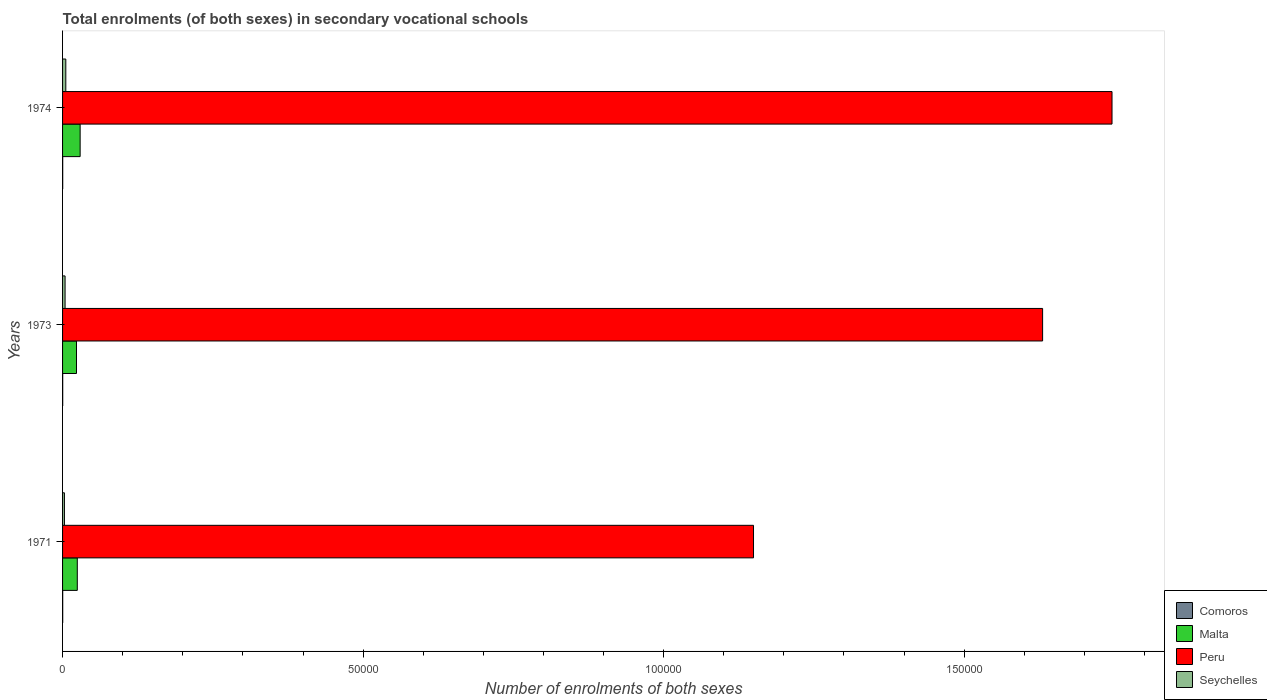How many bars are there on the 2nd tick from the top?
Provide a short and direct response. 4. What is the label of the 1st group of bars from the top?
Your answer should be very brief. 1974. What is the number of enrolments in secondary schools in Malta in 1973?
Make the answer very short. 2319. Across all years, what is the maximum number of enrolments in secondary schools in Peru?
Keep it short and to the point. 1.75e+05. Across all years, what is the minimum number of enrolments in secondary schools in Seychelles?
Provide a short and direct response. 312. In which year was the number of enrolments in secondary schools in Peru maximum?
Your answer should be compact. 1974. What is the total number of enrolments in secondary schools in Malta in the graph?
Keep it short and to the point. 7694. What is the difference between the number of enrolments in secondary schools in Peru in 1971 and that in 1973?
Offer a terse response. -4.81e+04. What is the difference between the number of enrolments in secondary schools in Comoros in 1971 and the number of enrolments in secondary schools in Seychelles in 1973?
Your answer should be compact. -394. What is the average number of enrolments in secondary schools in Peru per year?
Give a very brief answer. 1.51e+05. In the year 1971, what is the difference between the number of enrolments in secondary schools in Peru and number of enrolments in secondary schools in Seychelles?
Your answer should be compact. 1.15e+05. In how many years, is the number of enrolments in secondary schools in Comoros greater than 100000 ?
Offer a terse response. 0. What is the ratio of the number of enrolments in secondary schools in Seychelles in 1971 to that in 1974?
Your answer should be very brief. 0.58. Is the number of enrolments in secondary schools in Peru in 1971 less than that in 1973?
Give a very brief answer. Yes. What is the difference between the highest and the second highest number of enrolments in secondary schools in Peru?
Offer a very short reply. 1.15e+04. What is the difference between the highest and the lowest number of enrolments in secondary schools in Comoros?
Offer a very short reply. 2. In how many years, is the number of enrolments in secondary schools in Peru greater than the average number of enrolments in secondary schools in Peru taken over all years?
Your answer should be compact. 2. What does the 4th bar from the top in 1974 represents?
Your answer should be very brief. Comoros. What does the 3rd bar from the bottom in 1971 represents?
Your answer should be very brief. Peru. How many bars are there?
Provide a succinct answer. 12. What is the difference between two consecutive major ticks on the X-axis?
Make the answer very short. 5.00e+04. Does the graph contain any zero values?
Provide a succinct answer. No. How many legend labels are there?
Your answer should be compact. 4. How are the legend labels stacked?
Give a very brief answer. Vertical. What is the title of the graph?
Offer a very short reply. Total enrolments (of both sexes) in secondary vocational schools. Does "Comoros" appear as one of the legend labels in the graph?
Your response must be concise. Yes. What is the label or title of the X-axis?
Your answer should be compact. Number of enrolments of both sexes. What is the label or title of the Y-axis?
Provide a succinct answer. Years. What is the Number of enrolments of both sexes of Comoros in 1971?
Offer a very short reply. 24. What is the Number of enrolments of both sexes in Malta in 1971?
Offer a very short reply. 2450. What is the Number of enrolments of both sexes in Peru in 1971?
Provide a succinct answer. 1.15e+05. What is the Number of enrolments of both sexes of Seychelles in 1971?
Offer a terse response. 312. What is the Number of enrolments of both sexes in Comoros in 1973?
Keep it short and to the point. 23. What is the Number of enrolments of both sexes of Malta in 1973?
Offer a terse response. 2319. What is the Number of enrolments of both sexes of Peru in 1973?
Offer a terse response. 1.63e+05. What is the Number of enrolments of both sexes in Seychelles in 1973?
Provide a succinct answer. 418. What is the Number of enrolments of both sexes in Comoros in 1974?
Provide a short and direct response. 22. What is the Number of enrolments of both sexes of Malta in 1974?
Offer a very short reply. 2925. What is the Number of enrolments of both sexes in Peru in 1974?
Offer a terse response. 1.75e+05. What is the Number of enrolments of both sexes in Seychelles in 1974?
Provide a short and direct response. 540. Across all years, what is the maximum Number of enrolments of both sexes in Malta?
Keep it short and to the point. 2925. Across all years, what is the maximum Number of enrolments of both sexes of Peru?
Your response must be concise. 1.75e+05. Across all years, what is the maximum Number of enrolments of both sexes in Seychelles?
Offer a very short reply. 540. Across all years, what is the minimum Number of enrolments of both sexes of Malta?
Offer a terse response. 2319. Across all years, what is the minimum Number of enrolments of both sexes of Peru?
Your answer should be very brief. 1.15e+05. Across all years, what is the minimum Number of enrolments of both sexes in Seychelles?
Offer a very short reply. 312. What is the total Number of enrolments of both sexes of Comoros in the graph?
Make the answer very short. 69. What is the total Number of enrolments of both sexes in Malta in the graph?
Ensure brevity in your answer.  7694. What is the total Number of enrolments of both sexes in Peru in the graph?
Provide a short and direct response. 4.53e+05. What is the total Number of enrolments of both sexes of Seychelles in the graph?
Provide a succinct answer. 1270. What is the difference between the Number of enrolments of both sexes in Comoros in 1971 and that in 1973?
Make the answer very short. 1. What is the difference between the Number of enrolments of both sexes of Malta in 1971 and that in 1973?
Keep it short and to the point. 131. What is the difference between the Number of enrolments of both sexes in Peru in 1971 and that in 1973?
Give a very brief answer. -4.81e+04. What is the difference between the Number of enrolments of both sexes in Seychelles in 1971 and that in 1973?
Your response must be concise. -106. What is the difference between the Number of enrolments of both sexes of Malta in 1971 and that in 1974?
Make the answer very short. -475. What is the difference between the Number of enrolments of both sexes of Peru in 1971 and that in 1974?
Make the answer very short. -5.96e+04. What is the difference between the Number of enrolments of both sexes in Seychelles in 1971 and that in 1974?
Your answer should be compact. -228. What is the difference between the Number of enrolments of both sexes of Malta in 1973 and that in 1974?
Your response must be concise. -606. What is the difference between the Number of enrolments of both sexes in Peru in 1973 and that in 1974?
Provide a short and direct response. -1.15e+04. What is the difference between the Number of enrolments of both sexes in Seychelles in 1973 and that in 1974?
Provide a succinct answer. -122. What is the difference between the Number of enrolments of both sexes of Comoros in 1971 and the Number of enrolments of both sexes of Malta in 1973?
Offer a terse response. -2295. What is the difference between the Number of enrolments of both sexes in Comoros in 1971 and the Number of enrolments of both sexes in Peru in 1973?
Keep it short and to the point. -1.63e+05. What is the difference between the Number of enrolments of both sexes in Comoros in 1971 and the Number of enrolments of both sexes in Seychelles in 1973?
Your answer should be compact. -394. What is the difference between the Number of enrolments of both sexes of Malta in 1971 and the Number of enrolments of both sexes of Peru in 1973?
Your answer should be very brief. -1.61e+05. What is the difference between the Number of enrolments of both sexes in Malta in 1971 and the Number of enrolments of both sexes in Seychelles in 1973?
Offer a terse response. 2032. What is the difference between the Number of enrolments of both sexes of Peru in 1971 and the Number of enrolments of both sexes of Seychelles in 1973?
Your response must be concise. 1.15e+05. What is the difference between the Number of enrolments of both sexes of Comoros in 1971 and the Number of enrolments of both sexes of Malta in 1974?
Your answer should be very brief. -2901. What is the difference between the Number of enrolments of both sexes in Comoros in 1971 and the Number of enrolments of both sexes in Peru in 1974?
Offer a very short reply. -1.75e+05. What is the difference between the Number of enrolments of both sexes in Comoros in 1971 and the Number of enrolments of both sexes in Seychelles in 1974?
Ensure brevity in your answer.  -516. What is the difference between the Number of enrolments of both sexes of Malta in 1971 and the Number of enrolments of both sexes of Peru in 1974?
Give a very brief answer. -1.72e+05. What is the difference between the Number of enrolments of both sexes in Malta in 1971 and the Number of enrolments of both sexes in Seychelles in 1974?
Offer a very short reply. 1910. What is the difference between the Number of enrolments of both sexes in Peru in 1971 and the Number of enrolments of both sexes in Seychelles in 1974?
Provide a succinct answer. 1.14e+05. What is the difference between the Number of enrolments of both sexes in Comoros in 1973 and the Number of enrolments of both sexes in Malta in 1974?
Your response must be concise. -2902. What is the difference between the Number of enrolments of both sexes of Comoros in 1973 and the Number of enrolments of both sexes of Peru in 1974?
Provide a short and direct response. -1.75e+05. What is the difference between the Number of enrolments of both sexes of Comoros in 1973 and the Number of enrolments of both sexes of Seychelles in 1974?
Make the answer very short. -517. What is the difference between the Number of enrolments of both sexes in Malta in 1973 and the Number of enrolments of both sexes in Peru in 1974?
Your response must be concise. -1.72e+05. What is the difference between the Number of enrolments of both sexes of Malta in 1973 and the Number of enrolments of both sexes of Seychelles in 1974?
Your response must be concise. 1779. What is the difference between the Number of enrolments of both sexes in Peru in 1973 and the Number of enrolments of both sexes in Seychelles in 1974?
Keep it short and to the point. 1.63e+05. What is the average Number of enrolments of both sexes in Comoros per year?
Ensure brevity in your answer.  23. What is the average Number of enrolments of both sexes of Malta per year?
Keep it short and to the point. 2564.67. What is the average Number of enrolments of both sexes of Peru per year?
Your answer should be compact. 1.51e+05. What is the average Number of enrolments of both sexes in Seychelles per year?
Give a very brief answer. 423.33. In the year 1971, what is the difference between the Number of enrolments of both sexes in Comoros and Number of enrolments of both sexes in Malta?
Ensure brevity in your answer.  -2426. In the year 1971, what is the difference between the Number of enrolments of both sexes in Comoros and Number of enrolments of both sexes in Peru?
Offer a terse response. -1.15e+05. In the year 1971, what is the difference between the Number of enrolments of both sexes of Comoros and Number of enrolments of both sexes of Seychelles?
Offer a very short reply. -288. In the year 1971, what is the difference between the Number of enrolments of both sexes in Malta and Number of enrolments of both sexes in Peru?
Provide a succinct answer. -1.12e+05. In the year 1971, what is the difference between the Number of enrolments of both sexes of Malta and Number of enrolments of both sexes of Seychelles?
Keep it short and to the point. 2138. In the year 1971, what is the difference between the Number of enrolments of both sexes in Peru and Number of enrolments of both sexes in Seychelles?
Your answer should be compact. 1.15e+05. In the year 1973, what is the difference between the Number of enrolments of both sexes in Comoros and Number of enrolments of both sexes in Malta?
Your response must be concise. -2296. In the year 1973, what is the difference between the Number of enrolments of both sexes in Comoros and Number of enrolments of both sexes in Peru?
Your answer should be very brief. -1.63e+05. In the year 1973, what is the difference between the Number of enrolments of both sexes of Comoros and Number of enrolments of both sexes of Seychelles?
Offer a very short reply. -395. In the year 1973, what is the difference between the Number of enrolments of both sexes in Malta and Number of enrolments of both sexes in Peru?
Offer a terse response. -1.61e+05. In the year 1973, what is the difference between the Number of enrolments of both sexes in Malta and Number of enrolments of both sexes in Seychelles?
Give a very brief answer. 1901. In the year 1973, what is the difference between the Number of enrolments of both sexes of Peru and Number of enrolments of both sexes of Seychelles?
Your answer should be very brief. 1.63e+05. In the year 1974, what is the difference between the Number of enrolments of both sexes of Comoros and Number of enrolments of both sexes of Malta?
Ensure brevity in your answer.  -2903. In the year 1974, what is the difference between the Number of enrolments of both sexes in Comoros and Number of enrolments of both sexes in Peru?
Your answer should be compact. -1.75e+05. In the year 1974, what is the difference between the Number of enrolments of both sexes in Comoros and Number of enrolments of both sexes in Seychelles?
Provide a short and direct response. -518. In the year 1974, what is the difference between the Number of enrolments of both sexes of Malta and Number of enrolments of both sexes of Peru?
Keep it short and to the point. -1.72e+05. In the year 1974, what is the difference between the Number of enrolments of both sexes of Malta and Number of enrolments of both sexes of Seychelles?
Give a very brief answer. 2385. In the year 1974, what is the difference between the Number of enrolments of both sexes of Peru and Number of enrolments of both sexes of Seychelles?
Offer a terse response. 1.74e+05. What is the ratio of the Number of enrolments of both sexes in Comoros in 1971 to that in 1973?
Offer a very short reply. 1.04. What is the ratio of the Number of enrolments of both sexes of Malta in 1971 to that in 1973?
Make the answer very short. 1.06. What is the ratio of the Number of enrolments of both sexes of Peru in 1971 to that in 1973?
Offer a very short reply. 0.7. What is the ratio of the Number of enrolments of both sexes of Seychelles in 1971 to that in 1973?
Provide a succinct answer. 0.75. What is the ratio of the Number of enrolments of both sexes of Comoros in 1971 to that in 1974?
Keep it short and to the point. 1.09. What is the ratio of the Number of enrolments of both sexes in Malta in 1971 to that in 1974?
Keep it short and to the point. 0.84. What is the ratio of the Number of enrolments of both sexes in Peru in 1971 to that in 1974?
Provide a short and direct response. 0.66. What is the ratio of the Number of enrolments of both sexes of Seychelles in 1971 to that in 1974?
Your answer should be very brief. 0.58. What is the ratio of the Number of enrolments of both sexes of Comoros in 1973 to that in 1974?
Your answer should be compact. 1.05. What is the ratio of the Number of enrolments of both sexes in Malta in 1973 to that in 1974?
Your answer should be very brief. 0.79. What is the ratio of the Number of enrolments of both sexes in Peru in 1973 to that in 1974?
Offer a terse response. 0.93. What is the ratio of the Number of enrolments of both sexes of Seychelles in 1973 to that in 1974?
Your response must be concise. 0.77. What is the difference between the highest and the second highest Number of enrolments of both sexes of Comoros?
Provide a short and direct response. 1. What is the difference between the highest and the second highest Number of enrolments of both sexes of Malta?
Make the answer very short. 475. What is the difference between the highest and the second highest Number of enrolments of both sexes in Peru?
Make the answer very short. 1.15e+04. What is the difference between the highest and the second highest Number of enrolments of both sexes of Seychelles?
Your answer should be very brief. 122. What is the difference between the highest and the lowest Number of enrolments of both sexes in Comoros?
Make the answer very short. 2. What is the difference between the highest and the lowest Number of enrolments of both sexes in Malta?
Give a very brief answer. 606. What is the difference between the highest and the lowest Number of enrolments of both sexes of Peru?
Make the answer very short. 5.96e+04. What is the difference between the highest and the lowest Number of enrolments of both sexes in Seychelles?
Your answer should be compact. 228. 